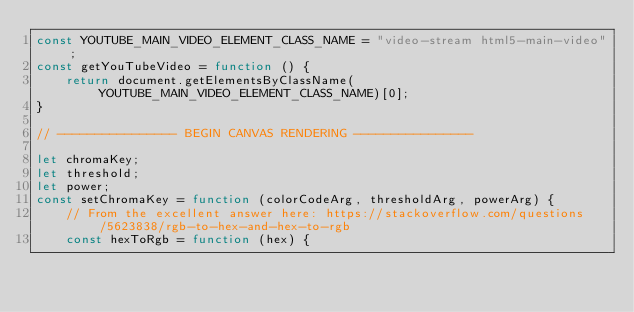Convert code to text. <code><loc_0><loc_0><loc_500><loc_500><_JavaScript_>const YOUTUBE_MAIN_VIDEO_ELEMENT_CLASS_NAME = "video-stream html5-main-video";
const getYouTubeVideo = function () {
    return document.getElementsByClassName(YOUTUBE_MAIN_VIDEO_ELEMENT_CLASS_NAME)[0];
}

// ---------------- BEGIN CANVAS RENDERING ----------------

let chromaKey;
let threshold;
let power;
const setChromaKey = function (colorCodeArg, thresholdArg, powerArg) {
    // From the excellent answer here: https://stackoverflow.com/questions/5623838/rgb-to-hex-and-hex-to-rgb
    const hexToRgb = function (hex) {</code> 